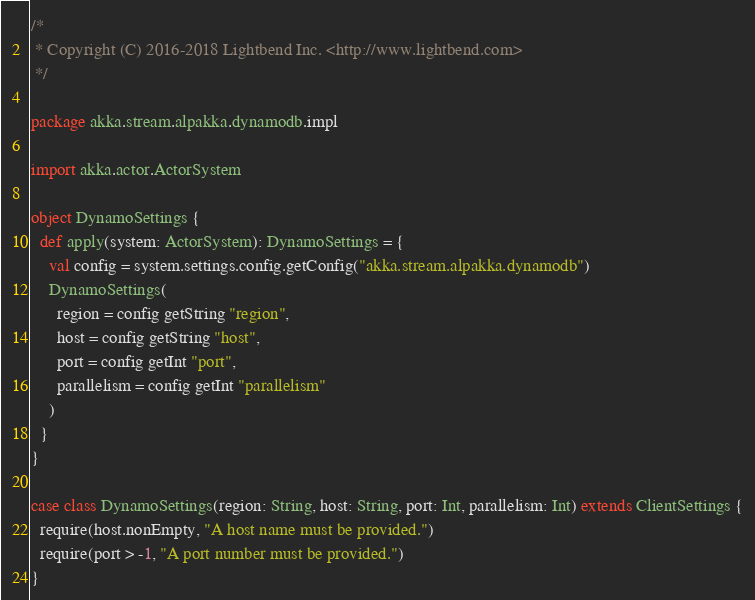Convert code to text. <code><loc_0><loc_0><loc_500><loc_500><_Scala_>/*
 * Copyright (C) 2016-2018 Lightbend Inc. <http://www.lightbend.com>
 */

package akka.stream.alpakka.dynamodb.impl

import akka.actor.ActorSystem

object DynamoSettings {
  def apply(system: ActorSystem): DynamoSettings = {
    val config = system.settings.config.getConfig("akka.stream.alpakka.dynamodb")
    DynamoSettings(
      region = config getString "region",
      host = config getString "host",
      port = config getInt "port",
      parallelism = config getInt "parallelism"
    )
  }
}

case class DynamoSettings(region: String, host: String, port: Int, parallelism: Int) extends ClientSettings {
  require(host.nonEmpty, "A host name must be provided.")
  require(port > -1, "A port number must be provided.")
}
</code> 